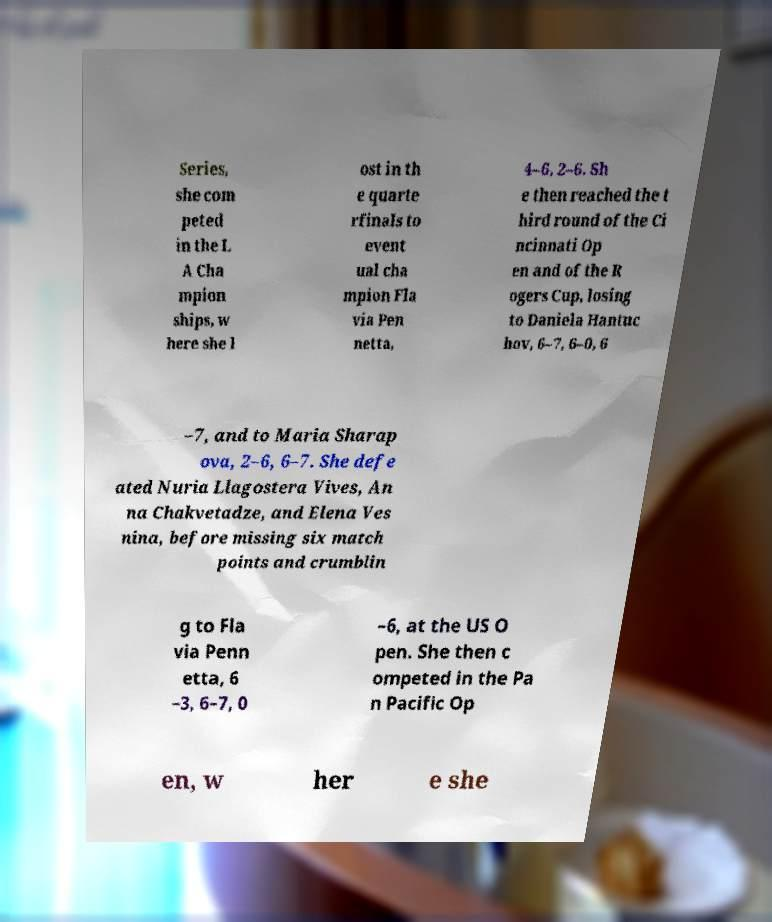Please read and relay the text visible in this image. What does it say? Series, she com peted in the L A Cha mpion ships, w here she l ost in th e quarte rfinals to event ual cha mpion Fla via Pen netta, 4–6, 2–6. Sh e then reached the t hird round of the Ci ncinnati Op en and of the R ogers Cup, losing to Daniela Hantuc hov, 6–7, 6–0, 6 –7, and to Maria Sharap ova, 2–6, 6–7. She defe ated Nuria Llagostera Vives, An na Chakvetadze, and Elena Ves nina, before missing six match points and crumblin g to Fla via Penn etta, 6 –3, 6–7, 0 –6, at the US O pen. She then c ompeted in the Pa n Pacific Op en, w her e she 